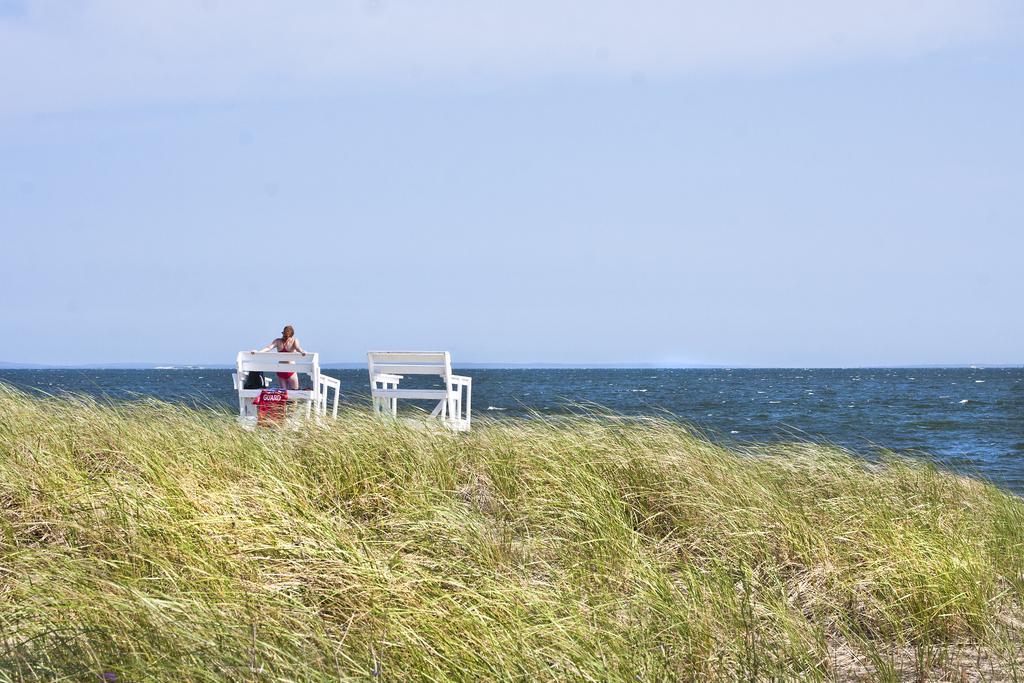How would you summarize this image in a sentence or two? In this image there are branches and grass on the ground. There is a woman standing on the bench. In front of her there is the water. At the top there is the sky. 